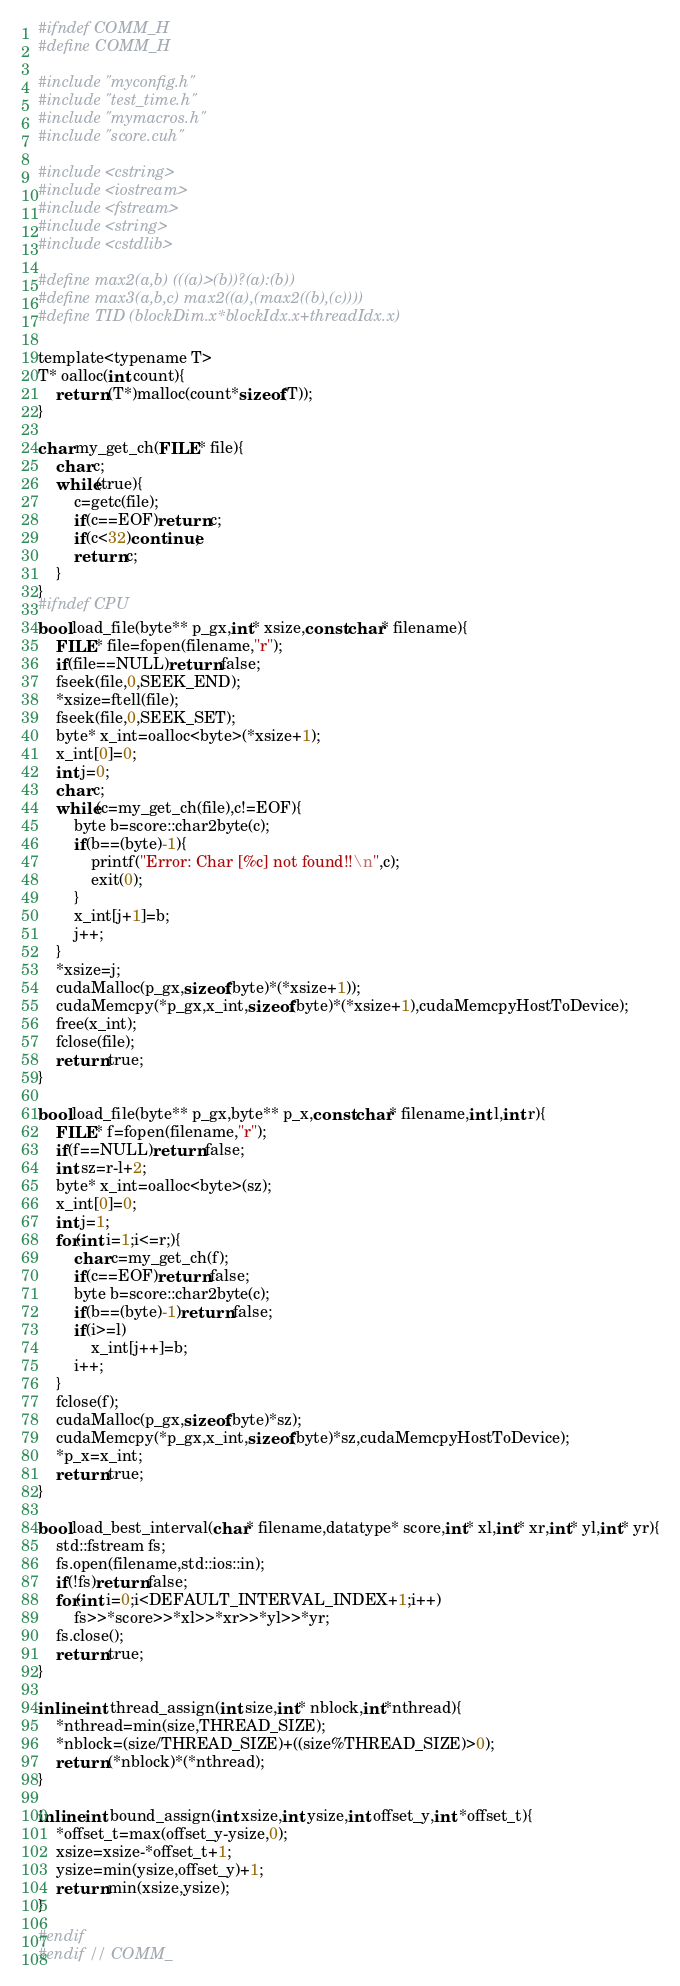<code> <loc_0><loc_0><loc_500><loc_500><_Cuda_>#ifndef COMM_H
#define COMM_H

#include "myconfig.h"
#include "test_time.h"
#include "mymacros.h"
#include "score.cuh"

#include <cstring>
#include <iostream>
#include <fstream>
#include <string>
#include <cstdlib>

#define max2(a,b) (((a)>(b))?(a):(b))
#define max3(a,b,c) max2((a),(max2((b),(c))))
#define TID (blockDim.x*blockIdx.x+threadIdx.x)

template<typename T>
T* oalloc(int count){
    return (T*)malloc(count*sizeof(T));
}

char my_get_ch(FILE* file){
    char c;
    while(true){
        c=getc(file);
        if(c==EOF)return c;
        if(c<32)continue;
        return c;
    }
}
#ifndef CPU
bool load_file(byte** p_gx,int* xsize,const char* filename){
    FILE* file=fopen(filename,"r");
    if(file==NULL)return false;
    fseek(file,0,SEEK_END);
    *xsize=ftell(file);
    fseek(file,0,SEEK_SET);
    byte* x_int=oalloc<byte>(*xsize+1);
    x_int[0]=0;
    int j=0;
    char c;
    while(c=my_get_ch(file),c!=EOF){
        byte b=score::char2byte(c);
        if(b==(byte)-1){
            printf("Error: Char [%c] not found!!\n",c);
            exit(0);
        }
        x_int[j+1]=b;
        j++;
    }
    *xsize=j;
    cudaMalloc(p_gx,sizeof(byte)*(*xsize+1));
    cudaMemcpy(*p_gx,x_int,sizeof(byte)*(*xsize+1),cudaMemcpyHostToDevice);
    free(x_int);
    fclose(file);
    return true;
}

bool load_file(byte** p_gx,byte** p_x,const char* filename,int l,int r){
    FILE* f=fopen(filename,"r");
    if(f==NULL)return false;
    int sz=r-l+2;
    byte* x_int=oalloc<byte>(sz);
    x_int[0]=0;
    int j=1;
    for(int i=1;i<=r;){
        char c=my_get_ch(f);
        if(c==EOF)return false;
        byte b=score::char2byte(c);
        if(b==(byte)-1)return false;
        if(i>=l)
            x_int[j++]=b;
        i++;
    }
    fclose(f);
    cudaMalloc(p_gx,sizeof(byte)*sz);
    cudaMemcpy(*p_gx,x_int,sizeof(byte)*sz,cudaMemcpyHostToDevice);
    *p_x=x_int;
    return true;
}

bool load_best_interval(char* filename,datatype* score,int* xl,int* xr,int* yl,int* yr){
    std::fstream fs;
    fs.open(filename,std::ios::in);
    if(!fs)return false;
    for(int i=0;i<DEFAULT_INTERVAL_INDEX+1;i++)
        fs>>*score>>*xl>>*xr>>*yl>>*yr;
    fs.close();
    return true;
}

inline int thread_assign(int size,int* nblock,int*nthread){
    *nthread=min(size,THREAD_SIZE);
    *nblock=(size/THREAD_SIZE)+((size%THREAD_SIZE)>0);
    return (*nblock)*(*nthread);
}

inline int bound_assign(int xsize,int ysize,int offset_y,int *offset_t){
    *offset_t=max(offset_y-ysize,0);
    xsize=xsize-*offset_t+1;
    ysize=min(ysize,offset_y)+1;
    return min(xsize,ysize);
}

#endif
#endif // COMM_</code> 